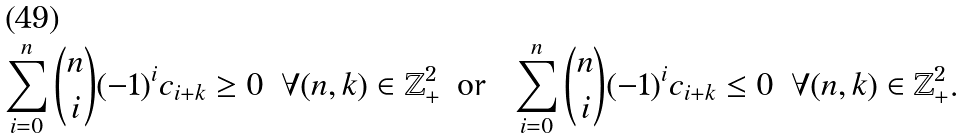<formula> <loc_0><loc_0><loc_500><loc_500>\sum _ { i = 0 } ^ { n } \binom { n } { i } ( - 1 ) ^ { i } c _ { i + k } & \geq 0 & \forall ( n , k ) & \in \mathbb { Z } ^ { 2 } _ { + } & & \text {or } & \sum _ { i = 0 } ^ { n } \binom { n } { i } ( - 1 ) ^ { i } c _ { i + k } & \leq 0 & \forall ( n , k ) & \in \mathbb { Z } ^ { 2 } _ { + } .</formula> 